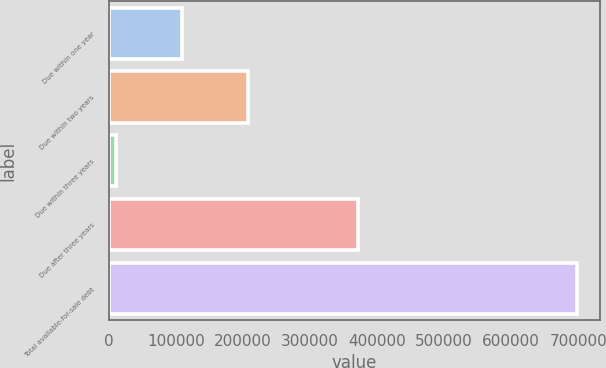<chart> <loc_0><loc_0><loc_500><loc_500><bar_chart><fcel>Due within one year<fcel>Due within two years<fcel>Due within three years<fcel>Due after three years<fcel>Total available-for-sale debt<nl><fcel>108753<fcel>207157<fcel>10379<fcel>371111<fcel>697400<nl></chart> 